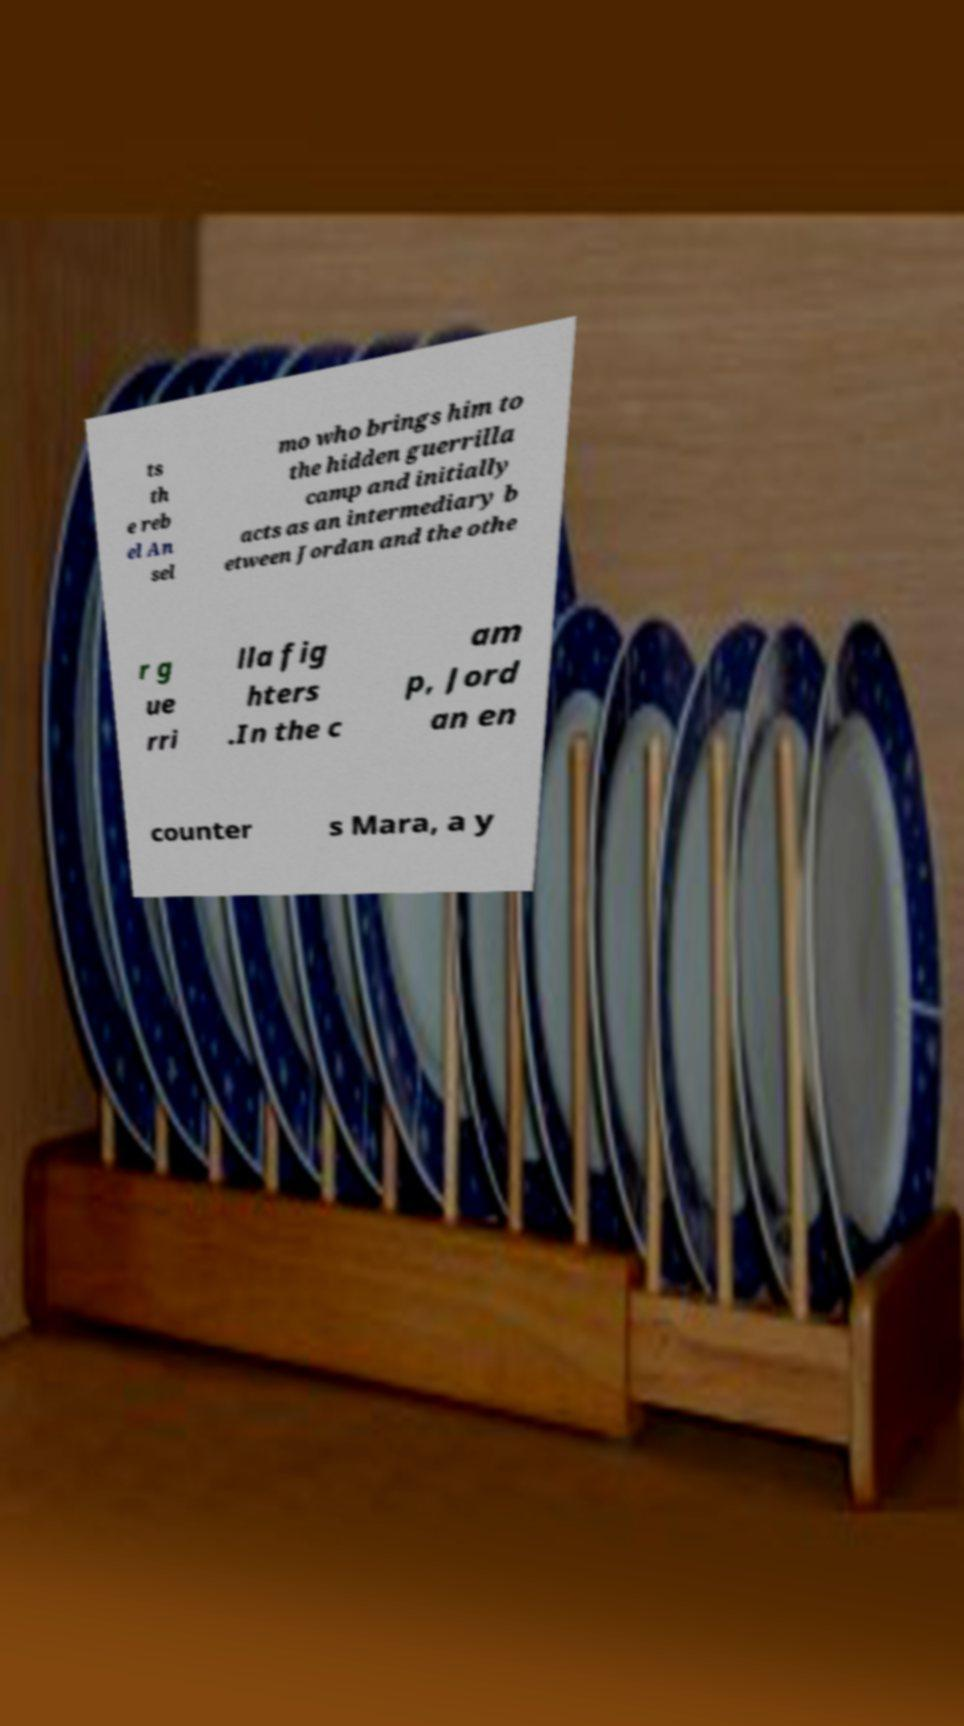For documentation purposes, I need the text within this image transcribed. Could you provide that? ts th e reb el An sel mo who brings him to the hidden guerrilla camp and initially acts as an intermediary b etween Jordan and the othe r g ue rri lla fig hters .In the c am p, Jord an en counter s Mara, a y 